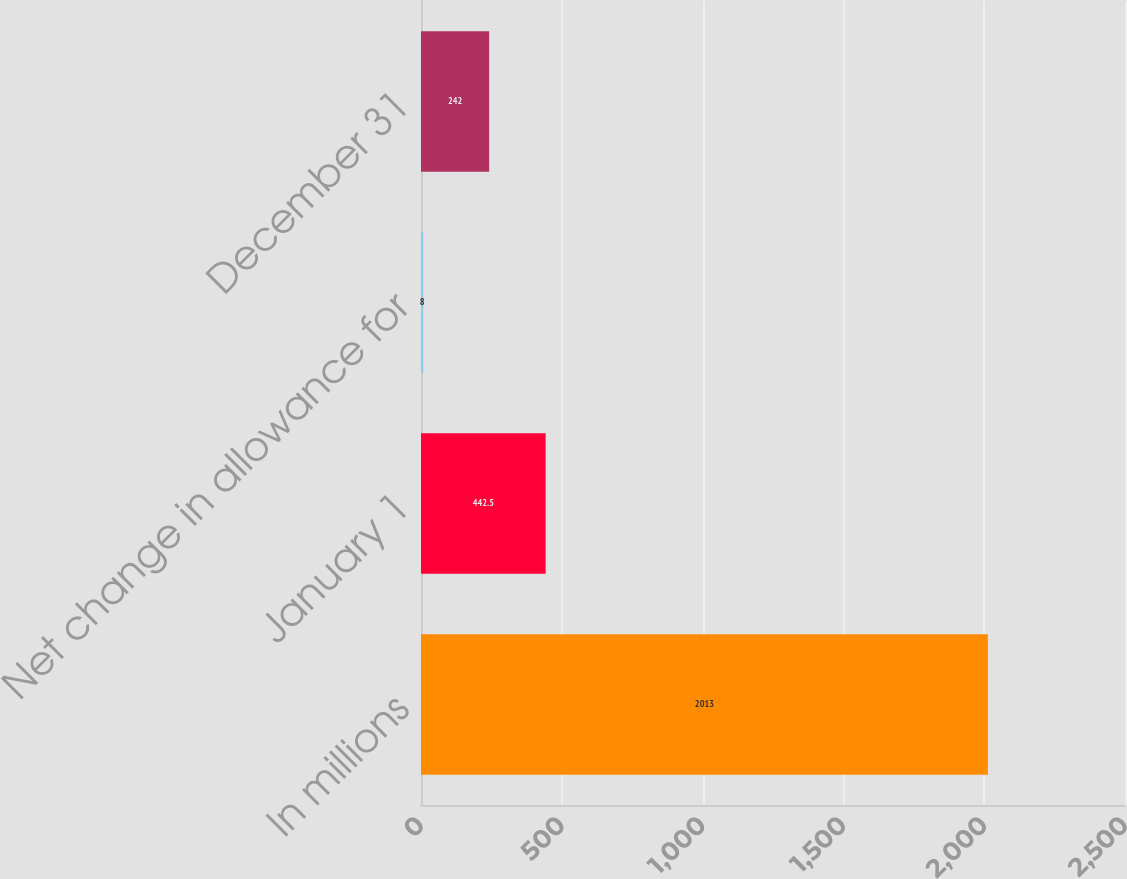<chart> <loc_0><loc_0><loc_500><loc_500><bar_chart><fcel>In millions<fcel>January 1<fcel>Net change in allowance for<fcel>December 31<nl><fcel>2013<fcel>442.5<fcel>8<fcel>242<nl></chart> 